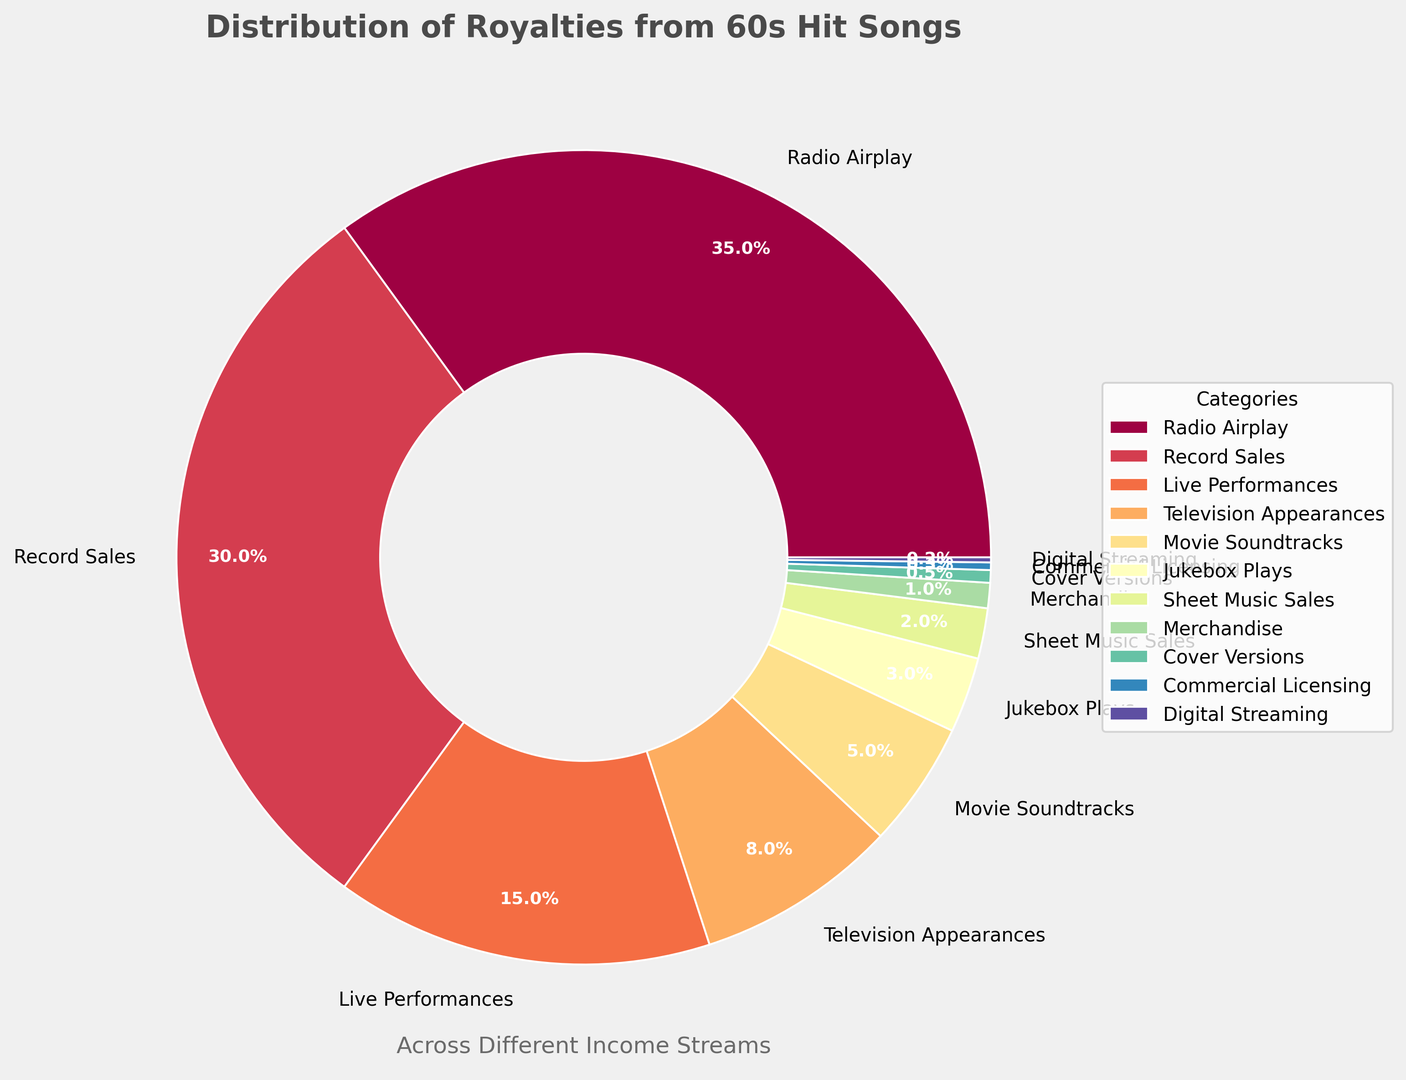What's the largest source of royalties according to the chart? The largest segment in the ring chart represents the highest source of royalties. By looking at the sizes, the segment labeled "Radio Airplay" is the largest.
Answer: Radio Airplay Which category contributes more to royalties, Movie Soundtracks or Digital Streaming? By directly comparing the sizes of the segments, the "Movie Soundtracks" segment is larger than the "Digital Streaming" segment.
Answer: Movie Soundtracks How do the combined contributions of Television Appearances and Merchandise compare to the contribution from Record Sales? First, sum the percentages for Television Appearances (8) and Merchandise (1), which results in 9. Then, compare this combined total to Record Sales (30). Since 9 is less than 30, Record Sales contributes more.
Answer: Record Sales What proportion of royalties comes from categories contributing less than 5% each? Sum the percentages of Jukebox Plays (3), Sheet Music Sales (2), Merchandise (1), Cover Versions (0.5), Commercial Licensing (0.3), and Digital Streaming (0.2). The total is 7.
Answer: 7 Among the categories, which one has the smallest contribution? The segment labeled "Digital Streaming" is the smallest in the ring chart.
Answer: Digital Streaming What's the combined percentage of royalties from Live Performances and Television Appearances? Sum the percentages for Live Performances (15) and Television Appearances (8), resulting in 23.
Answer: 23 Is the sum of royalties from Jukebox Plays, Sheet Music Sales, and Merchandise greater than Live Performances? Sum the percentages for Jukebox Plays (3), Sheet Music Sales (2), and Merchandise (1), resulting in 6. Compare this total to Live Performances (15). Since 6 is less than 15, Live Performances contribute more.
Answer: No If you remove the top two sources of royalties, what percentage remains? Subtract the percentages of the top two sources, Radio Airplay (35) and Record Sales (30), from 100%. The remaining percentage is 100 - 35 - 30 = 35.
Answer: 35 Which category, Live Performances or Commercial Licensing, has a larger contribution, and by what factor? Live Performances have a contribution of 15% and Commercial Licensing has 0.3%. The factor difference is 15 / 0.3 = 50.
Answer: Live Performances by 50 times What percentage of royalties comes from cover versions? The segment labeled "Cover Versions" shows a percentage of 0.5.
Answer: 0.5 